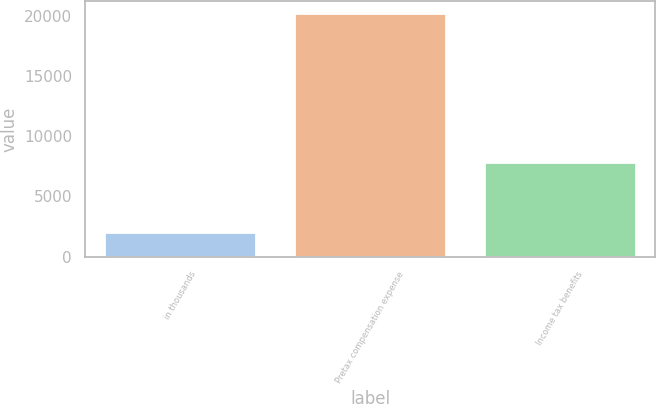Convert chart to OTSL. <chart><loc_0><loc_0><loc_500><loc_500><bar_chart><fcel>in thousands<fcel>Pretax compensation expense<fcel>Income tax benefits<nl><fcel>2013<fcel>20187<fcel>7833<nl></chart> 